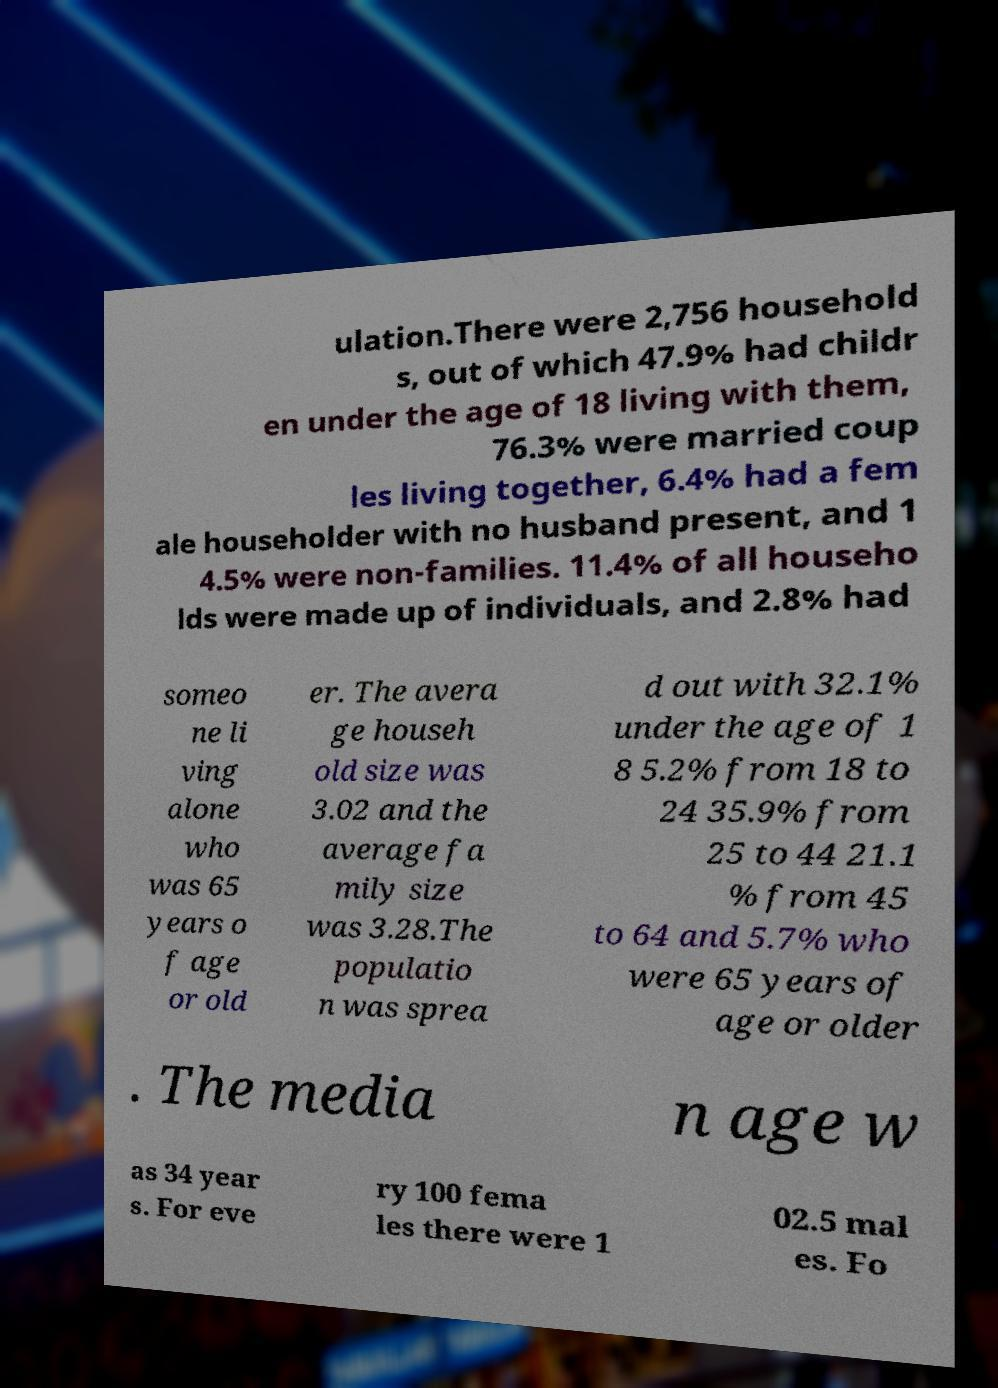Can you read and provide the text displayed in the image?This photo seems to have some interesting text. Can you extract and type it out for me? ulation.There were 2,756 household s, out of which 47.9% had childr en under the age of 18 living with them, 76.3% were married coup les living together, 6.4% had a fem ale householder with no husband present, and 1 4.5% were non-families. 11.4% of all househo lds were made up of individuals, and 2.8% had someo ne li ving alone who was 65 years o f age or old er. The avera ge househ old size was 3.02 and the average fa mily size was 3.28.The populatio n was sprea d out with 32.1% under the age of 1 8 5.2% from 18 to 24 35.9% from 25 to 44 21.1 % from 45 to 64 and 5.7% who were 65 years of age or older . The media n age w as 34 year s. For eve ry 100 fema les there were 1 02.5 mal es. Fo 